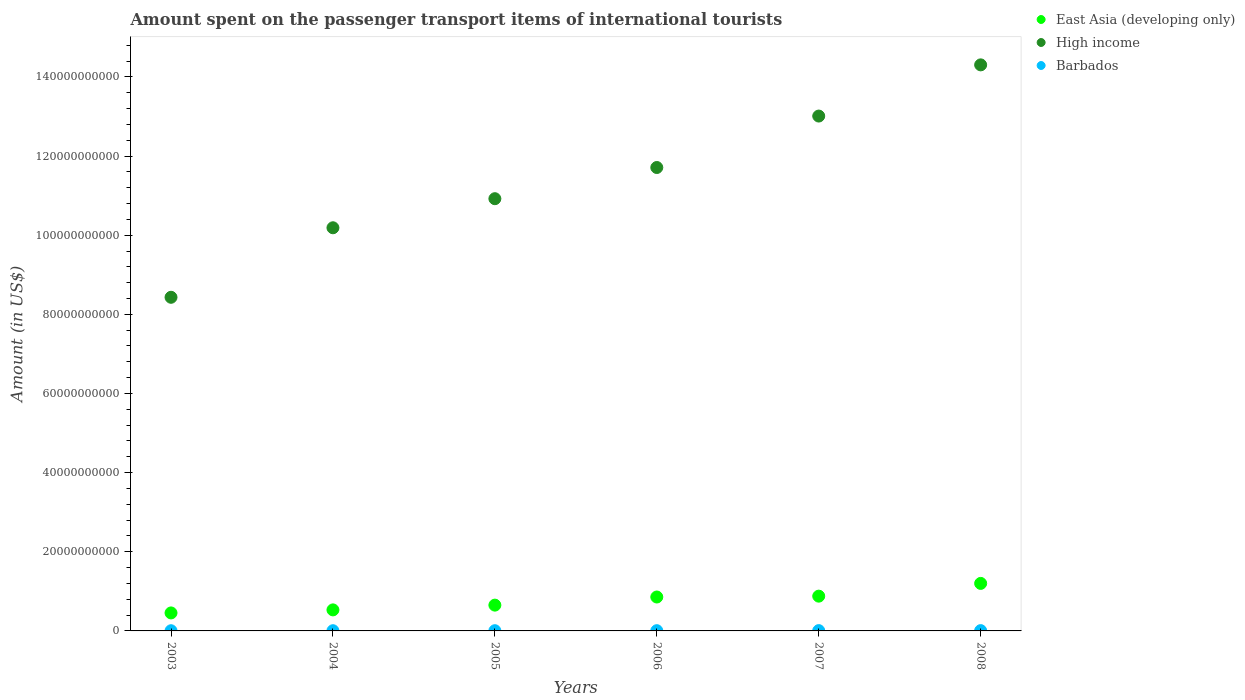How many different coloured dotlines are there?
Keep it short and to the point. 3. Is the number of dotlines equal to the number of legend labels?
Provide a succinct answer. Yes. What is the amount spent on the passenger transport items of international tourists in High income in 2005?
Your response must be concise. 1.09e+11. Across all years, what is the maximum amount spent on the passenger transport items of international tourists in High income?
Ensure brevity in your answer.  1.43e+11. Across all years, what is the minimum amount spent on the passenger transport items of international tourists in High income?
Your answer should be compact. 8.43e+1. In which year was the amount spent on the passenger transport items of international tourists in East Asia (developing only) maximum?
Your answer should be very brief. 2008. What is the total amount spent on the passenger transport items of international tourists in High income in the graph?
Give a very brief answer. 6.86e+11. What is the difference between the amount spent on the passenger transport items of international tourists in High income in 2007 and that in 2008?
Your response must be concise. -1.29e+1. What is the difference between the amount spent on the passenger transport items of international tourists in High income in 2003 and the amount spent on the passenger transport items of international tourists in East Asia (developing only) in 2007?
Make the answer very short. 7.55e+1. What is the average amount spent on the passenger transport items of international tourists in Barbados per year?
Your response must be concise. 6.25e+07. In the year 2004, what is the difference between the amount spent on the passenger transport items of international tourists in East Asia (developing only) and amount spent on the passenger transport items of international tourists in High income?
Provide a succinct answer. -9.66e+1. In how many years, is the amount spent on the passenger transport items of international tourists in East Asia (developing only) greater than 76000000000 US$?
Make the answer very short. 0. What is the ratio of the amount spent on the passenger transport items of international tourists in Barbados in 2004 to that in 2005?
Keep it short and to the point. 0.96. What is the difference between the highest and the second highest amount spent on the passenger transport items of international tourists in High income?
Keep it short and to the point. 1.29e+1. What is the difference between the highest and the lowest amount spent on the passenger transport items of international tourists in High income?
Offer a terse response. 5.87e+1. In how many years, is the amount spent on the passenger transport items of international tourists in East Asia (developing only) greater than the average amount spent on the passenger transport items of international tourists in East Asia (developing only) taken over all years?
Provide a short and direct response. 3. Is the amount spent on the passenger transport items of international tourists in East Asia (developing only) strictly less than the amount spent on the passenger transport items of international tourists in Barbados over the years?
Provide a short and direct response. No. How many dotlines are there?
Your response must be concise. 3. Does the graph contain any zero values?
Give a very brief answer. No. Where does the legend appear in the graph?
Keep it short and to the point. Top right. How many legend labels are there?
Your response must be concise. 3. How are the legend labels stacked?
Your answer should be very brief. Vertical. What is the title of the graph?
Provide a succinct answer. Amount spent on the passenger transport items of international tourists. What is the Amount (in US$) in East Asia (developing only) in 2003?
Your response must be concise. 4.55e+09. What is the Amount (in US$) in High income in 2003?
Your answer should be very brief. 8.43e+1. What is the Amount (in US$) in Barbados in 2003?
Offer a terse response. 4.90e+07. What is the Amount (in US$) in East Asia (developing only) in 2004?
Your answer should be very brief. 5.32e+09. What is the Amount (in US$) of High income in 2004?
Keep it short and to the point. 1.02e+11. What is the Amount (in US$) of Barbados in 2004?
Provide a succinct answer. 5.50e+07. What is the Amount (in US$) in East Asia (developing only) in 2005?
Your response must be concise. 6.52e+09. What is the Amount (in US$) in High income in 2005?
Your response must be concise. 1.09e+11. What is the Amount (in US$) in Barbados in 2005?
Provide a short and direct response. 5.70e+07. What is the Amount (in US$) in East Asia (developing only) in 2006?
Your answer should be compact. 8.57e+09. What is the Amount (in US$) in High income in 2006?
Provide a short and direct response. 1.17e+11. What is the Amount (in US$) in Barbados in 2006?
Your answer should be very brief. 6.20e+07. What is the Amount (in US$) of East Asia (developing only) in 2007?
Your answer should be compact. 8.79e+09. What is the Amount (in US$) in High income in 2007?
Provide a succinct answer. 1.30e+11. What is the Amount (in US$) of Barbados in 2007?
Your answer should be compact. 7.80e+07. What is the Amount (in US$) of East Asia (developing only) in 2008?
Provide a succinct answer. 1.20e+1. What is the Amount (in US$) of High income in 2008?
Provide a short and direct response. 1.43e+11. What is the Amount (in US$) of Barbados in 2008?
Keep it short and to the point. 7.40e+07. Across all years, what is the maximum Amount (in US$) in East Asia (developing only)?
Offer a terse response. 1.20e+1. Across all years, what is the maximum Amount (in US$) in High income?
Your response must be concise. 1.43e+11. Across all years, what is the maximum Amount (in US$) of Barbados?
Ensure brevity in your answer.  7.80e+07. Across all years, what is the minimum Amount (in US$) in East Asia (developing only)?
Keep it short and to the point. 4.55e+09. Across all years, what is the minimum Amount (in US$) in High income?
Your answer should be compact. 8.43e+1. Across all years, what is the minimum Amount (in US$) in Barbados?
Ensure brevity in your answer.  4.90e+07. What is the total Amount (in US$) in East Asia (developing only) in the graph?
Your answer should be compact. 4.57e+1. What is the total Amount (in US$) in High income in the graph?
Your answer should be very brief. 6.86e+11. What is the total Amount (in US$) in Barbados in the graph?
Offer a very short reply. 3.75e+08. What is the difference between the Amount (in US$) of East Asia (developing only) in 2003 and that in 2004?
Your answer should be very brief. -7.70e+08. What is the difference between the Amount (in US$) of High income in 2003 and that in 2004?
Provide a short and direct response. -1.76e+1. What is the difference between the Amount (in US$) in Barbados in 2003 and that in 2004?
Your answer should be very brief. -6.00e+06. What is the difference between the Amount (in US$) of East Asia (developing only) in 2003 and that in 2005?
Provide a succinct answer. -1.97e+09. What is the difference between the Amount (in US$) in High income in 2003 and that in 2005?
Offer a terse response. -2.49e+1. What is the difference between the Amount (in US$) of Barbados in 2003 and that in 2005?
Your response must be concise. -8.00e+06. What is the difference between the Amount (in US$) in East Asia (developing only) in 2003 and that in 2006?
Keep it short and to the point. -4.02e+09. What is the difference between the Amount (in US$) of High income in 2003 and that in 2006?
Your response must be concise. -3.28e+1. What is the difference between the Amount (in US$) of Barbados in 2003 and that in 2006?
Give a very brief answer. -1.30e+07. What is the difference between the Amount (in US$) in East Asia (developing only) in 2003 and that in 2007?
Your response must be concise. -4.24e+09. What is the difference between the Amount (in US$) of High income in 2003 and that in 2007?
Keep it short and to the point. -4.58e+1. What is the difference between the Amount (in US$) of Barbados in 2003 and that in 2007?
Ensure brevity in your answer.  -2.90e+07. What is the difference between the Amount (in US$) of East Asia (developing only) in 2003 and that in 2008?
Your answer should be very brief. -7.46e+09. What is the difference between the Amount (in US$) in High income in 2003 and that in 2008?
Offer a terse response. -5.87e+1. What is the difference between the Amount (in US$) in Barbados in 2003 and that in 2008?
Ensure brevity in your answer.  -2.50e+07. What is the difference between the Amount (in US$) in East Asia (developing only) in 2004 and that in 2005?
Your response must be concise. -1.20e+09. What is the difference between the Amount (in US$) of High income in 2004 and that in 2005?
Give a very brief answer. -7.35e+09. What is the difference between the Amount (in US$) in East Asia (developing only) in 2004 and that in 2006?
Your answer should be compact. -3.25e+09. What is the difference between the Amount (in US$) in High income in 2004 and that in 2006?
Make the answer very short. -1.52e+1. What is the difference between the Amount (in US$) in Barbados in 2004 and that in 2006?
Offer a terse response. -7.00e+06. What is the difference between the Amount (in US$) of East Asia (developing only) in 2004 and that in 2007?
Your answer should be very brief. -3.47e+09. What is the difference between the Amount (in US$) of High income in 2004 and that in 2007?
Provide a short and direct response. -2.82e+1. What is the difference between the Amount (in US$) of Barbados in 2004 and that in 2007?
Provide a short and direct response. -2.30e+07. What is the difference between the Amount (in US$) of East Asia (developing only) in 2004 and that in 2008?
Your answer should be very brief. -6.69e+09. What is the difference between the Amount (in US$) in High income in 2004 and that in 2008?
Offer a terse response. -4.12e+1. What is the difference between the Amount (in US$) of Barbados in 2004 and that in 2008?
Keep it short and to the point. -1.90e+07. What is the difference between the Amount (in US$) in East Asia (developing only) in 2005 and that in 2006?
Your answer should be very brief. -2.05e+09. What is the difference between the Amount (in US$) in High income in 2005 and that in 2006?
Keep it short and to the point. -7.88e+09. What is the difference between the Amount (in US$) in Barbados in 2005 and that in 2006?
Your response must be concise. -5.00e+06. What is the difference between the Amount (in US$) in East Asia (developing only) in 2005 and that in 2007?
Provide a short and direct response. -2.27e+09. What is the difference between the Amount (in US$) of High income in 2005 and that in 2007?
Offer a terse response. -2.09e+1. What is the difference between the Amount (in US$) in Barbados in 2005 and that in 2007?
Ensure brevity in your answer.  -2.10e+07. What is the difference between the Amount (in US$) of East Asia (developing only) in 2005 and that in 2008?
Give a very brief answer. -5.49e+09. What is the difference between the Amount (in US$) in High income in 2005 and that in 2008?
Your answer should be compact. -3.38e+1. What is the difference between the Amount (in US$) in Barbados in 2005 and that in 2008?
Keep it short and to the point. -1.70e+07. What is the difference between the Amount (in US$) of East Asia (developing only) in 2006 and that in 2007?
Give a very brief answer. -2.16e+08. What is the difference between the Amount (in US$) in High income in 2006 and that in 2007?
Make the answer very short. -1.30e+1. What is the difference between the Amount (in US$) of Barbados in 2006 and that in 2007?
Provide a short and direct response. -1.60e+07. What is the difference between the Amount (in US$) of East Asia (developing only) in 2006 and that in 2008?
Your response must be concise. -3.44e+09. What is the difference between the Amount (in US$) of High income in 2006 and that in 2008?
Make the answer very short. -2.59e+1. What is the difference between the Amount (in US$) in Barbados in 2006 and that in 2008?
Your answer should be very brief. -1.20e+07. What is the difference between the Amount (in US$) of East Asia (developing only) in 2007 and that in 2008?
Your answer should be compact. -3.22e+09. What is the difference between the Amount (in US$) of High income in 2007 and that in 2008?
Offer a very short reply. -1.29e+1. What is the difference between the Amount (in US$) of Barbados in 2007 and that in 2008?
Keep it short and to the point. 4.00e+06. What is the difference between the Amount (in US$) in East Asia (developing only) in 2003 and the Amount (in US$) in High income in 2004?
Offer a very short reply. -9.73e+1. What is the difference between the Amount (in US$) in East Asia (developing only) in 2003 and the Amount (in US$) in Barbados in 2004?
Make the answer very short. 4.49e+09. What is the difference between the Amount (in US$) in High income in 2003 and the Amount (in US$) in Barbados in 2004?
Make the answer very short. 8.43e+1. What is the difference between the Amount (in US$) of East Asia (developing only) in 2003 and the Amount (in US$) of High income in 2005?
Keep it short and to the point. -1.05e+11. What is the difference between the Amount (in US$) of East Asia (developing only) in 2003 and the Amount (in US$) of Barbados in 2005?
Provide a short and direct response. 4.49e+09. What is the difference between the Amount (in US$) in High income in 2003 and the Amount (in US$) in Barbados in 2005?
Your answer should be compact. 8.42e+1. What is the difference between the Amount (in US$) in East Asia (developing only) in 2003 and the Amount (in US$) in High income in 2006?
Your answer should be very brief. -1.13e+11. What is the difference between the Amount (in US$) of East Asia (developing only) in 2003 and the Amount (in US$) of Barbados in 2006?
Offer a very short reply. 4.48e+09. What is the difference between the Amount (in US$) of High income in 2003 and the Amount (in US$) of Barbados in 2006?
Ensure brevity in your answer.  8.42e+1. What is the difference between the Amount (in US$) of East Asia (developing only) in 2003 and the Amount (in US$) of High income in 2007?
Make the answer very short. -1.26e+11. What is the difference between the Amount (in US$) in East Asia (developing only) in 2003 and the Amount (in US$) in Barbados in 2007?
Offer a terse response. 4.47e+09. What is the difference between the Amount (in US$) of High income in 2003 and the Amount (in US$) of Barbados in 2007?
Make the answer very short. 8.42e+1. What is the difference between the Amount (in US$) in East Asia (developing only) in 2003 and the Amount (in US$) in High income in 2008?
Provide a short and direct response. -1.38e+11. What is the difference between the Amount (in US$) of East Asia (developing only) in 2003 and the Amount (in US$) of Barbados in 2008?
Ensure brevity in your answer.  4.47e+09. What is the difference between the Amount (in US$) in High income in 2003 and the Amount (in US$) in Barbados in 2008?
Your response must be concise. 8.42e+1. What is the difference between the Amount (in US$) in East Asia (developing only) in 2004 and the Amount (in US$) in High income in 2005?
Offer a terse response. -1.04e+11. What is the difference between the Amount (in US$) in East Asia (developing only) in 2004 and the Amount (in US$) in Barbados in 2005?
Your answer should be very brief. 5.26e+09. What is the difference between the Amount (in US$) in High income in 2004 and the Amount (in US$) in Barbados in 2005?
Ensure brevity in your answer.  1.02e+11. What is the difference between the Amount (in US$) of East Asia (developing only) in 2004 and the Amount (in US$) of High income in 2006?
Your response must be concise. -1.12e+11. What is the difference between the Amount (in US$) in East Asia (developing only) in 2004 and the Amount (in US$) in Barbados in 2006?
Make the answer very short. 5.25e+09. What is the difference between the Amount (in US$) in High income in 2004 and the Amount (in US$) in Barbados in 2006?
Give a very brief answer. 1.02e+11. What is the difference between the Amount (in US$) of East Asia (developing only) in 2004 and the Amount (in US$) of High income in 2007?
Provide a short and direct response. -1.25e+11. What is the difference between the Amount (in US$) in East Asia (developing only) in 2004 and the Amount (in US$) in Barbados in 2007?
Offer a terse response. 5.24e+09. What is the difference between the Amount (in US$) of High income in 2004 and the Amount (in US$) of Barbados in 2007?
Offer a very short reply. 1.02e+11. What is the difference between the Amount (in US$) in East Asia (developing only) in 2004 and the Amount (in US$) in High income in 2008?
Give a very brief answer. -1.38e+11. What is the difference between the Amount (in US$) in East Asia (developing only) in 2004 and the Amount (in US$) in Barbados in 2008?
Offer a very short reply. 5.24e+09. What is the difference between the Amount (in US$) in High income in 2004 and the Amount (in US$) in Barbados in 2008?
Your answer should be compact. 1.02e+11. What is the difference between the Amount (in US$) in East Asia (developing only) in 2005 and the Amount (in US$) in High income in 2006?
Ensure brevity in your answer.  -1.11e+11. What is the difference between the Amount (in US$) in East Asia (developing only) in 2005 and the Amount (in US$) in Barbados in 2006?
Offer a terse response. 6.46e+09. What is the difference between the Amount (in US$) of High income in 2005 and the Amount (in US$) of Barbados in 2006?
Ensure brevity in your answer.  1.09e+11. What is the difference between the Amount (in US$) of East Asia (developing only) in 2005 and the Amount (in US$) of High income in 2007?
Keep it short and to the point. -1.24e+11. What is the difference between the Amount (in US$) of East Asia (developing only) in 2005 and the Amount (in US$) of Barbados in 2007?
Your answer should be very brief. 6.44e+09. What is the difference between the Amount (in US$) of High income in 2005 and the Amount (in US$) of Barbados in 2007?
Your answer should be very brief. 1.09e+11. What is the difference between the Amount (in US$) in East Asia (developing only) in 2005 and the Amount (in US$) in High income in 2008?
Keep it short and to the point. -1.37e+11. What is the difference between the Amount (in US$) in East Asia (developing only) in 2005 and the Amount (in US$) in Barbados in 2008?
Make the answer very short. 6.44e+09. What is the difference between the Amount (in US$) in High income in 2005 and the Amount (in US$) in Barbados in 2008?
Give a very brief answer. 1.09e+11. What is the difference between the Amount (in US$) of East Asia (developing only) in 2006 and the Amount (in US$) of High income in 2007?
Keep it short and to the point. -1.22e+11. What is the difference between the Amount (in US$) in East Asia (developing only) in 2006 and the Amount (in US$) in Barbados in 2007?
Provide a succinct answer. 8.49e+09. What is the difference between the Amount (in US$) in High income in 2006 and the Amount (in US$) in Barbados in 2007?
Make the answer very short. 1.17e+11. What is the difference between the Amount (in US$) in East Asia (developing only) in 2006 and the Amount (in US$) in High income in 2008?
Give a very brief answer. -1.34e+11. What is the difference between the Amount (in US$) of East Asia (developing only) in 2006 and the Amount (in US$) of Barbados in 2008?
Provide a succinct answer. 8.50e+09. What is the difference between the Amount (in US$) of High income in 2006 and the Amount (in US$) of Barbados in 2008?
Ensure brevity in your answer.  1.17e+11. What is the difference between the Amount (in US$) in East Asia (developing only) in 2007 and the Amount (in US$) in High income in 2008?
Your answer should be compact. -1.34e+11. What is the difference between the Amount (in US$) in East Asia (developing only) in 2007 and the Amount (in US$) in Barbados in 2008?
Provide a short and direct response. 8.71e+09. What is the difference between the Amount (in US$) of High income in 2007 and the Amount (in US$) of Barbados in 2008?
Give a very brief answer. 1.30e+11. What is the average Amount (in US$) of East Asia (developing only) per year?
Ensure brevity in your answer.  7.62e+09. What is the average Amount (in US$) of High income per year?
Your answer should be compact. 1.14e+11. What is the average Amount (in US$) in Barbados per year?
Ensure brevity in your answer.  6.25e+07. In the year 2003, what is the difference between the Amount (in US$) of East Asia (developing only) and Amount (in US$) of High income?
Give a very brief answer. -7.98e+1. In the year 2003, what is the difference between the Amount (in US$) of East Asia (developing only) and Amount (in US$) of Barbados?
Make the answer very short. 4.50e+09. In the year 2003, what is the difference between the Amount (in US$) of High income and Amount (in US$) of Barbados?
Give a very brief answer. 8.43e+1. In the year 2004, what is the difference between the Amount (in US$) of East Asia (developing only) and Amount (in US$) of High income?
Give a very brief answer. -9.66e+1. In the year 2004, what is the difference between the Amount (in US$) in East Asia (developing only) and Amount (in US$) in Barbados?
Provide a succinct answer. 5.26e+09. In the year 2004, what is the difference between the Amount (in US$) in High income and Amount (in US$) in Barbados?
Your answer should be compact. 1.02e+11. In the year 2005, what is the difference between the Amount (in US$) in East Asia (developing only) and Amount (in US$) in High income?
Provide a short and direct response. -1.03e+11. In the year 2005, what is the difference between the Amount (in US$) in East Asia (developing only) and Amount (in US$) in Barbados?
Give a very brief answer. 6.46e+09. In the year 2005, what is the difference between the Amount (in US$) of High income and Amount (in US$) of Barbados?
Offer a very short reply. 1.09e+11. In the year 2006, what is the difference between the Amount (in US$) in East Asia (developing only) and Amount (in US$) in High income?
Your answer should be very brief. -1.09e+11. In the year 2006, what is the difference between the Amount (in US$) in East Asia (developing only) and Amount (in US$) in Barbados?
Your response must be concise. 8.51e+09. In the year 2006, what is the difference between the Amount (in US$) in High income and Amount (in US$) in Barbados?
Offer a terse response. 1.17e+11. In the year 2007, what is the difference between the Amount (in US$) in East Asia (developing only) and Amount (in US$) in High income?
Offer a terse response. -1.21e+11. In the year 2007, what is the difference between the Amount (in US$) of East Asia (developing only) and Amount (in US$) of Barbados?
Your response must be concise. 8.71e+09. In the year 2007, what is the difference between the Amount (in US$) in High income and Amount (in US$) in Barbados?
Make the answer very short. 1.30e+11. In the year 2008, what is the difference between the Amount (in US$) of East Asia (developing only) and Amount (in US$) of High income?
Make the answer very short. -1.31e+11. In the year 2008, what is the difference between the Amount (in US$) of East Asia (developing only) and Amount (in US$) of Barbados?
Offer a terse response. 1.19e+1. In the year 2008, what is the difference between the Amount (in US$) in High income and Amount (in US$) in Barbados?
Keep it short and to the point. 1.43e+11. What is the ratio of the Amount (in US$) in East Asia (developing only) in 2003 to that in 2004?
Offer a terse response. 0.86. What is the ratio of the Amount (in US$) of High income in 2003 to that in 2004?
Make the answer very short. 0.83. What is the ratio of the Amount (in US$) of Barbados in 2003 to that in 2004?
Your answer should be very brief. 0.89. What is the ratio of the Amount (in US$) of East Asia (developing only) in 2003 to that in 2005?
Offer a terse response. 0.7. What is the ratio of the Amount (in US$) in High income in 2003 to that in 2005?
Your answer should be compact. 0.77. What is the ratio of the Amount (in US$) in Barbados in 2003 to that in 2005?
Give a very brief answer. 0.86. What is the ratio of the Amount (in US$) in East Asia (developing only) in 2003 to that in 2006?
Offer a very short reply. 0.53. What is the ratio of the Amount (in US$) in High income in 2003 to that in 2006?
Ensure brevity in your answer.  0.72. What is the ratio of the Amount (in US$) of Barbados in 2003 to that in 2006?
Provide a succinct answer. 0.79. What is the ratio of the Amount (in US$) in East Asia (developing only) in 2003 to that in 2007?
Ensure brevity in your answer.  0.52. What is the ratio of the Amount (in US$) of High income in 2003 to that in 2007?
Offer a very short reply. 0.65. What is the ratio of the Amount (in US$) in Barbados in 2003 to that in 2007?
Your answer should be compact. 0.63. What is the ratio of the Amount (in US$) in East Asia (developing only) in 2003 to that in 2008?
Your response must be concise. 0.38. What is the ratio of the Amount (in US$) of High income in 2003 to that in 2008?
Provide a succinct answer. 0.59. What is the ratio of the Amount (in US$) of Barbados in 2003 to that in 2008?
Provide a succinct answer. 0.66. What is the ratio of the Amount (in US$) in East Asia (developing only) in 2004 to that in 2005?
Your answer should be compact. 0.82. What is the ratio of the Amount (in US$) in High income in 2004 to that in 2005?
Make the answer very short. 0.93. What is the ratio of the Amount (in US$) of Barbados in 2004 to that in 2005?
Your response must be concise. 0.96. What is the ratio of the Amount (in US$) in East Asia (developing only) in 2004 to that in 2006?
Give a very brief answer. 0.62. What is the ratio of the Amount (in US$) of High income in 2004 to that in 2006?
Ensure brevity in your answer.  0.87. What is the ratio of the Amount (in US$) of Barbados in 2004 to that in 2006?
Keep it short and to the point. 0.89. What is the ratio of the Amount (in US$) in East Asia (developing only) in 2004 to that in 2007?
Your response must be concise. 0.6. What is the ratio of the Amount (in US$) of High income in 2004 to that in 2007?
Provide a succinct answer. 0.78. What is the ratio of the Amount (in US$) in Barbados in 2004 to that in 2007?
Offer a very short reply. 0.71. What is the ratio of the Amount (in US$) of East Asia (developing only) in 2004 to that in 2008?
Offer a terse response. 0.44. What is the ratio of the Amount (in US$) in High income in 2004 to that in 2008?
Provide a short and direct response. 0.71. What is the ratio of the Amount (in US$) of Barbados in 2004 to that in 2008?
Provide a succinct answer. 0.74. What is the ratio of the Amount (in US$) of East Asia (developing only) in 2005 to that in 2006?
Keep it short and to the point. 0.76. What is the ratio of the Amount (in US$) of High income in 2005 to that in 2006?
Your answer should be compact. 0.93. What is the ratio of the Amount (in US$) of Barbados in 2005 to that in 2006?
Your response must be concise. 0.92. What is the ratio of the Amount (in US$) of East Asia (developing only) in 2005 to that in 2007?
Offer a terse response. 0.74. What is the ratio of the Amount (in US$) in High income in 2005 to that in 2007?
Your answer should be very brief. 0.84. What is the ratio of the Amount (in US$) of Barbados in 2005 to that in 2007?
Offer a terse response. 0.73. What is the ratio of the Amount (in US$) in East Asia (developing only) in 2005 to that in 2008?
Offer a very short reply. 0.54. What is the ratio of the Amount (in US$) in High income in 2005 to that in 2008?
Your answer should be very brief. 0.76. What is the ratio of the Amount (in US$) of Barbados in 2005 to that in 2008?
Your response must be concise. 0.77. What is the ratio of the Amount (in US$) of East Asia (developing only) in 2006 to that in 2007?
Your response must be concise. 0.98. What is the ratio of the Amount (in US$) in High income in 2006 to that in 2007?
Offer a terse response. 0.9. What is the ratio of the Amount (in US$) of Barbados in 2006 to that in 2007?
Ensure brevity in your answer.  0.79. What is the ratio of the Amount (in US$) of East Asia (developing only) in 2006 to that in 2008?
Offer a terse response. 0.71. What is the ratio of the Amount (in US$) of High income in 2006 to that in 2008?
Provide a short and direct response. 0.82. What is the ratio of the Amount (in US$) of Barbados in 2006 to that in 2008?
Give a very brief answer. 0.84. What is the ratio of the Amount (in US$) of East Asia (developing only) in 2007 to that in 2008?
Give a very brief answer. 0.73. What is the ratio of the Amount (in US$) in High income in 2007 to that in 2008?
Your response must be concise. 0.91. What is the ratio of the Amount (in US$) of Barbados in 2007 to that in 2008?
Your response must be concise. 1.05. What is the difference between the highest and the second highest Amount (in US$) of East Asia (developing only)?
Ensure brevity in your answer.  3.22e+09. What is the difference between the highest and the second highest Amount (in US$) in High income?
Your answer should be very brief. 1.29e+1. What is the difference between the highest and the second highest Amount (in US$) in Barbados?
Give a very brief answer. 4.00e+06. What is the difference between the highest and the lowest Amount (in US$) of East Asia (developing only)?
Your answer should be very brief. 7.46e+09. What is the difference between the highest and the lowest Amount (in US$) of High income?
Provide a succinct answer. 5.87e+1. What is the difference between the highest and the lowest Amount (in US$) in Barbados?
Ensure brevity in your answer.  2.90e+07. 